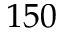Convert formula to latex. <formula><loc_0><loc_0><loc_500><loc_500>1 5 0</formula> 